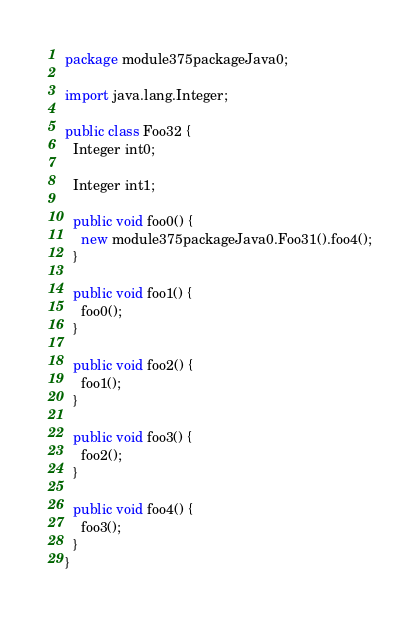Convert code to text. <code><loc_0><loc_0><loc_500><loc_500><_Java_>package module375packageJava0;

import java.lang.Integer;

public class Foo32 {
  Integer int0;

  Integer int1;

  public void foo0() {
    new module375packageJava0.Foo31().foo4();
  }

  public void foo1() {
    foo0();
  }

  public void foo2() {
    foo1();
  }

  public void foo3() {
    foo2();
  }

  public void foo4() {
    foo3();
  }
}
</code> 